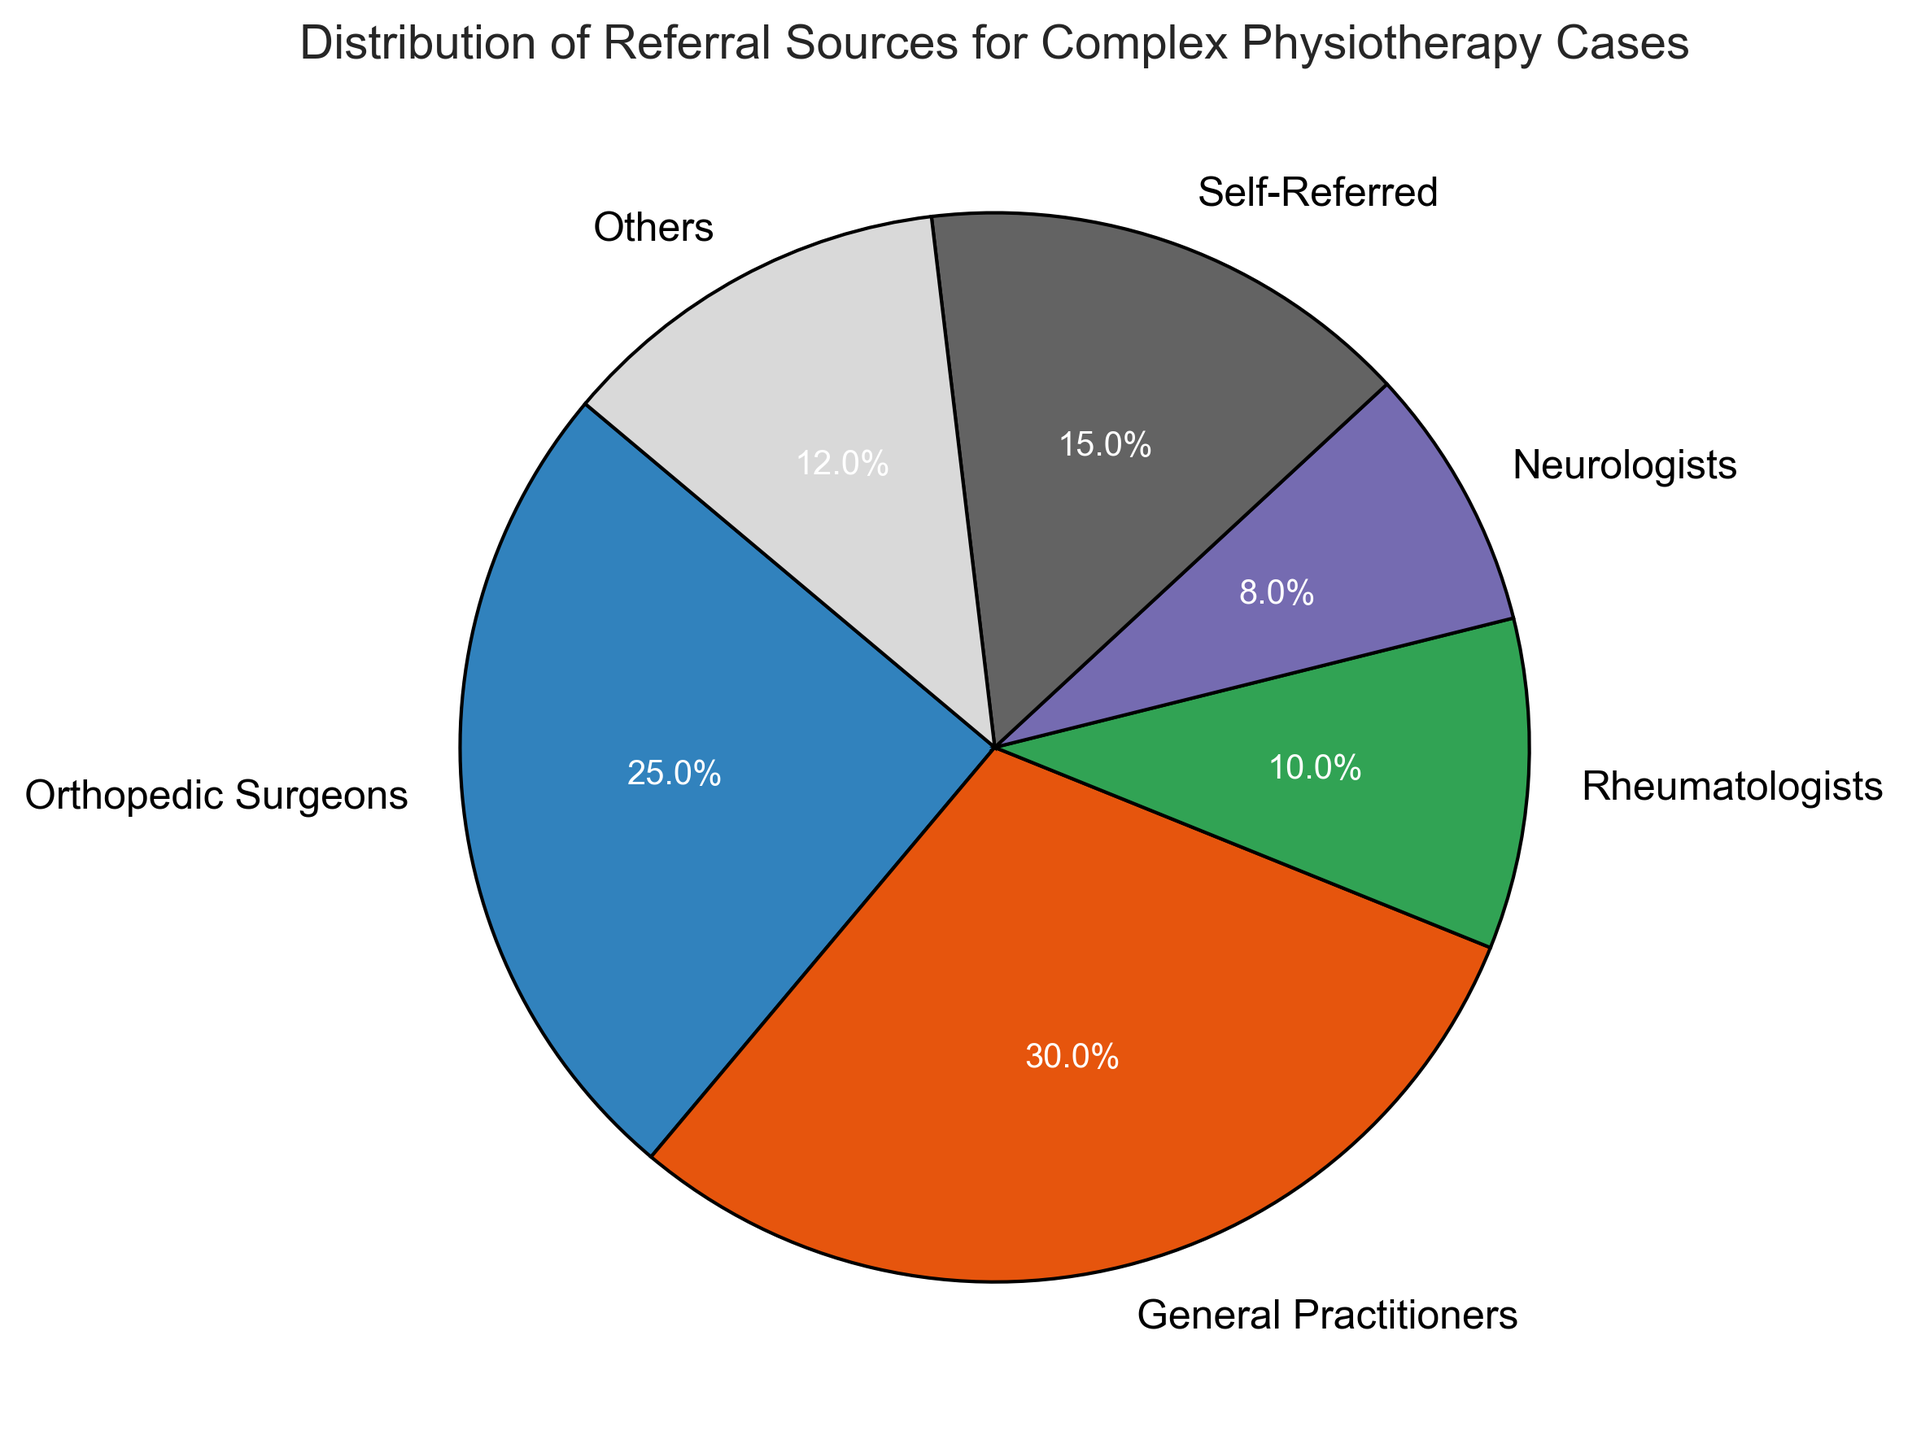What percentage of referrals come from Orthopedic Surgeons? The pie chart shows that Orthopedic Surgeons account for 25% of the referrals.
Answer: 25% What is the combined percentage of referrals from General Practitioners and Self-Referred sources? General Practitioners contribute 30% and Self-Referred sources contribute 15%. Adding these together, 30% + 15% = 45%.
Answer: 45% Which referral source has the smallest percentage? The pie chart indicates that Neurologists have the smallest percentage at 8%.
Answer: Neurologists How much greater is the percentage of referrals from General Practitioners compared to Rheumatologists? The General Practitioners account for 30% while Rheumatologists account for 10%. The difference is 30% - 10% = 20%.
Answer: 20% Are there more referrals from Self-Referred sources or from Neurologists? The pie chart shows that Self-Referred sources account for 15% while Neurologists account for 8%, so there are more referrals from Self-Referred sources.
Answer: Self-Referred If you add up the percentages of referrals from Orthopedic Surgeons, Rheumatologists, and Others, what is the total? Orthopedic Surgeons contribute 25%, Rheumatologists contribute 10%, and Others contribute 12%. The total is 25% + 10% + 12% = 47%.
Answer: 47% Which referral source has a percentage closer to the mean percentage of all sources? The mean percentage of all sources is calculated by summing the percentages (25% + 30% + 10% + 8% + 15% + 12% = 100%) and dividing by the number of sources (6), so 100% / 6 = 16.67%. The closest percentage is Self-Referred at 15%.
Answer: Self-Referred How do the percentages of referrals from General Practitioners and Others compare in terms of size? General Practitioners contribute 30% of referrals, while Others contribute 12%. General Practitioners have a higher percentage.
Answer: General Practitioners have a higher percentage What fraction of the referrals comes from Rheumatologists? Rheumatologists account for 10% of referrals. As a fraction, this is 10/100 or 1/10.
Answer: 1/10 